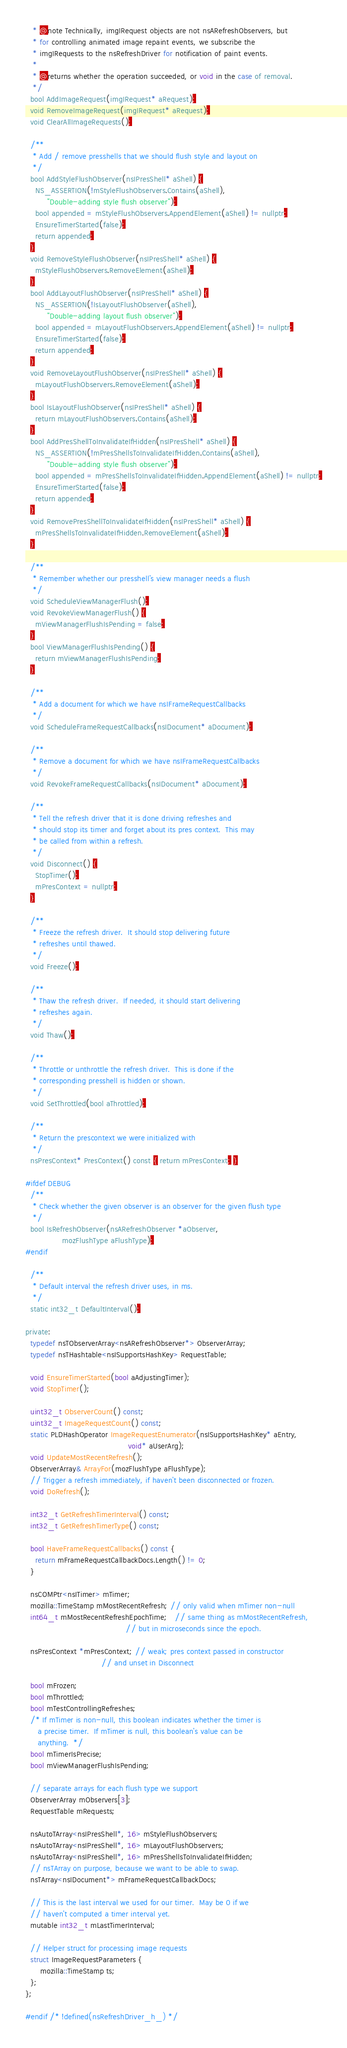Convert code to text. <code><loc_0><loc_0><loc_500><loc_500><_C_>   * @note Technically, imgIRequest objects are not nsARefreshObservers, but
   * for controlling animated image repaint events, we subscribe the
   * imgIRequests to the nsRefreshDriver for notification of paint events.
   *
   * @returns whether the operation succeeded, or void in the case of removal.
   */
  bool AddImageRequest(imgIRequest* aRequest);
  void RemoveImageRequest(imgIRequest* aRequest);
  void ClearAllImageRequests();

  /**
   * Add / remove presshells that we should flush style and layout on
   */
  bool AddStyleFlushObserver(nsIPresShell* aShell) {
    NS_ASSERTION(!mStyleFlushObservers.Contains(aShell),
		 "Double-adding style flush observer");
    bool appended = mStyleFlushObservers.AppendElement(aShell) != nullptr;
    EnsureTimerStarted(false);
    return appended;
  }
  void RemoveStyleFlushObserver(nsIPresShell* aShell) {
    mStyleFlushObservers.RemoveElement(aShell);
  }
  bool AddLayoutFlushObserver(nsIPresShell* aShell) {
    NS_ASSERTION(!IsLayoutFlushObserver(aShell),
		 "Double-adding layout flush observer");
    bool appended = mLayoutFlushObservers.AppendElement(aShell) != nullptr;
    EnsureTimerStarted(false);
    return appended;
  }
  void RemoveLayoutFlushObserver(nsIPresShell* aShell) {
    mLayoutFlushObservers.RemoveElement(aShell);
  }
  bool IsLayoutFlushObserver(nsIPresShell* aShell) {
    return mLayoutFlushObservers.Contains(aShell);
  }
  bool AddPresShellToInvalidateIfHidden(nsIPresShell* aShell) {
    NS_ASSERTION(!mPresShellsToInvalidateIfHidden.Contains(aShell),
		 "Double-adding style flush observer");
    bool appended = mPresShellsToInvalidateIfHidden.AppendElement(aShell) != nullptr;
    EnsureTimerStarted(false);
    return appended;
  }
  void RemovePresShellToInvalidateIfHidden(nsIPresShell* aShell) {
    mPresShellsToInvalidateIfHidden.RemoveElement(aShell);
  }

  /**
   * Remember whether our presshell's view manager needs a flush
   */
  void ScheduleViewManagerFlush();
  void RevokeViewManagerFlush() {
    mViewManagerFlushIsPending = false;
  }
  bool ViewManagerFlushIsPending() {
    return mViewManagerFlushIsPending;
  }

  /**
   * Add a document for which we have nsIFrameRequestCallbacks
   */
  void ScheduleFrameRequestCallbacks(nsIDocument* aDocument);

  /**
   * Remove a document for which we have nsIFrameRequestCallbacks
   */
  void RevokeFrameRequestCallbacks(nsIDocument* aDocument);

  /**
   * Tell the refresh driver that it is done driving refreshes and
   * should stop its timer and forget about its pres context.  This may
   * be called from within a refresh.
   */
  void Disconnect() {
    StopTimer();
    mPresContext = nullptr;
  }

  /**
   * Freeze the refresh driver.  It should stop delivering future
   * refreshes until thawed.
   */
  void Freeze();

  /**
   * Thaw the refresh driver.  If needed, it should start delivering
   * refreshes again.
   */
  void Thaw();

  /**
   * Throttle or unthrottle the refresh driver.  This is done if the
   * corresponding presshell is hidden or shown.
   */
  void SetThrottled(bool aThrottled);

  /**
   * Return the prescontext we were initialized with
   */
  nsPresContext* PresContext() const { return mPresContext; }

#ifdef DEBUG
  /**
   * Check whether the given observer is an observer for the given flush type
   */
  bool IsRefreshObserver(nsARefreshObserver *aObserver,
			   mozFlushType aFlushType);
#endif

  /**
   * Default interval the refresh driver uses, in ms.
   */
  static int32_t DefaultInterval();

private:
  typedef nsTObserverArray<nsARefreshObserver*> ObserverArray;
  typedef nsTHashtable<nsISupportsHashKey> RequestTable;

  void EnsureTimerStarted(bool aAdjustingTimer);
  void StopTimer();

  uint32_t ObserverCount() const;
  uint32_t ImageRequestCount() const;
  static PLDHashOperator ImageRequestEnumerator(nsISupportsHashKey* aEntry,
                                          void* aUserArg);
  void UpdateMostRecentRefresh();
  ObserverArray& ArrayFor(mozFlushType aFlushType);
  // Trigger a refresh immediately, if haven't been disconnected or frozen.
  void DoRefresh();

  int32_t GetRefreshTimerInterval() const;
  int32_t GetRefreshTimerType() const;

  bool HaveFrameRequestCallbacks() const {
    return mFrameRequestCallbackDocs.Length() != 0;
  }

  nsCOMPtr<nsITimer> mTimer;
  mozilla::TimeStamp mMostRecentRefresh; // only valid when mTimer non-null
  int64_t mMostRecentRefreshEpochTime;   // same thing as mMostRecentRefresh,
                                         // but in microseconds since the epoch.

  nsPresContext *mPresContext; // weak; pres context passed in constructor
                               // and unset in Disconnect

  bool mFrozen;
  bool mThrottled;
  bool mTestControllingRefreshes;
  /* If mTimer is non-null, this boolean indicates whether the timer is
     a precise timer.  If mTimer is null, this boolean's value can be
     anything.  */
  bool mTimerIsPrecise;
  bool mViewManagerFlushIsPending;

  // separate arrays for each flush type we support
  ObserverArray mObservers[3];
  RequestTable mRequests;

  nsAutoTArray<nsIPresShell*, 16> mStyleFlushObservers;
  nsAutoTArray<nsIPresShell*, 16> mLayoutFlushObservers;
  nsAutoTArray<nsIPresShell*, 16> mPresShellsToInvalidateIfHidden;
  // nsTArray on purpose, because we want to be able to swap.
  nsTArray<nsIDocument*> mFrameRequestCallbackDocs;

  // This is the last interval we used for our timer.  May be 0 if we
  // haven't computed a timer interval yet.
  mutable int32_t mLastTimerInterval;

  // Helper struct for processing image requests
  struct ImageRequestParameters {
      mozilla::TimeStamp ts;
  };
};

#endif /* !defined(nsRefreshDriver_h_) */
</code> 